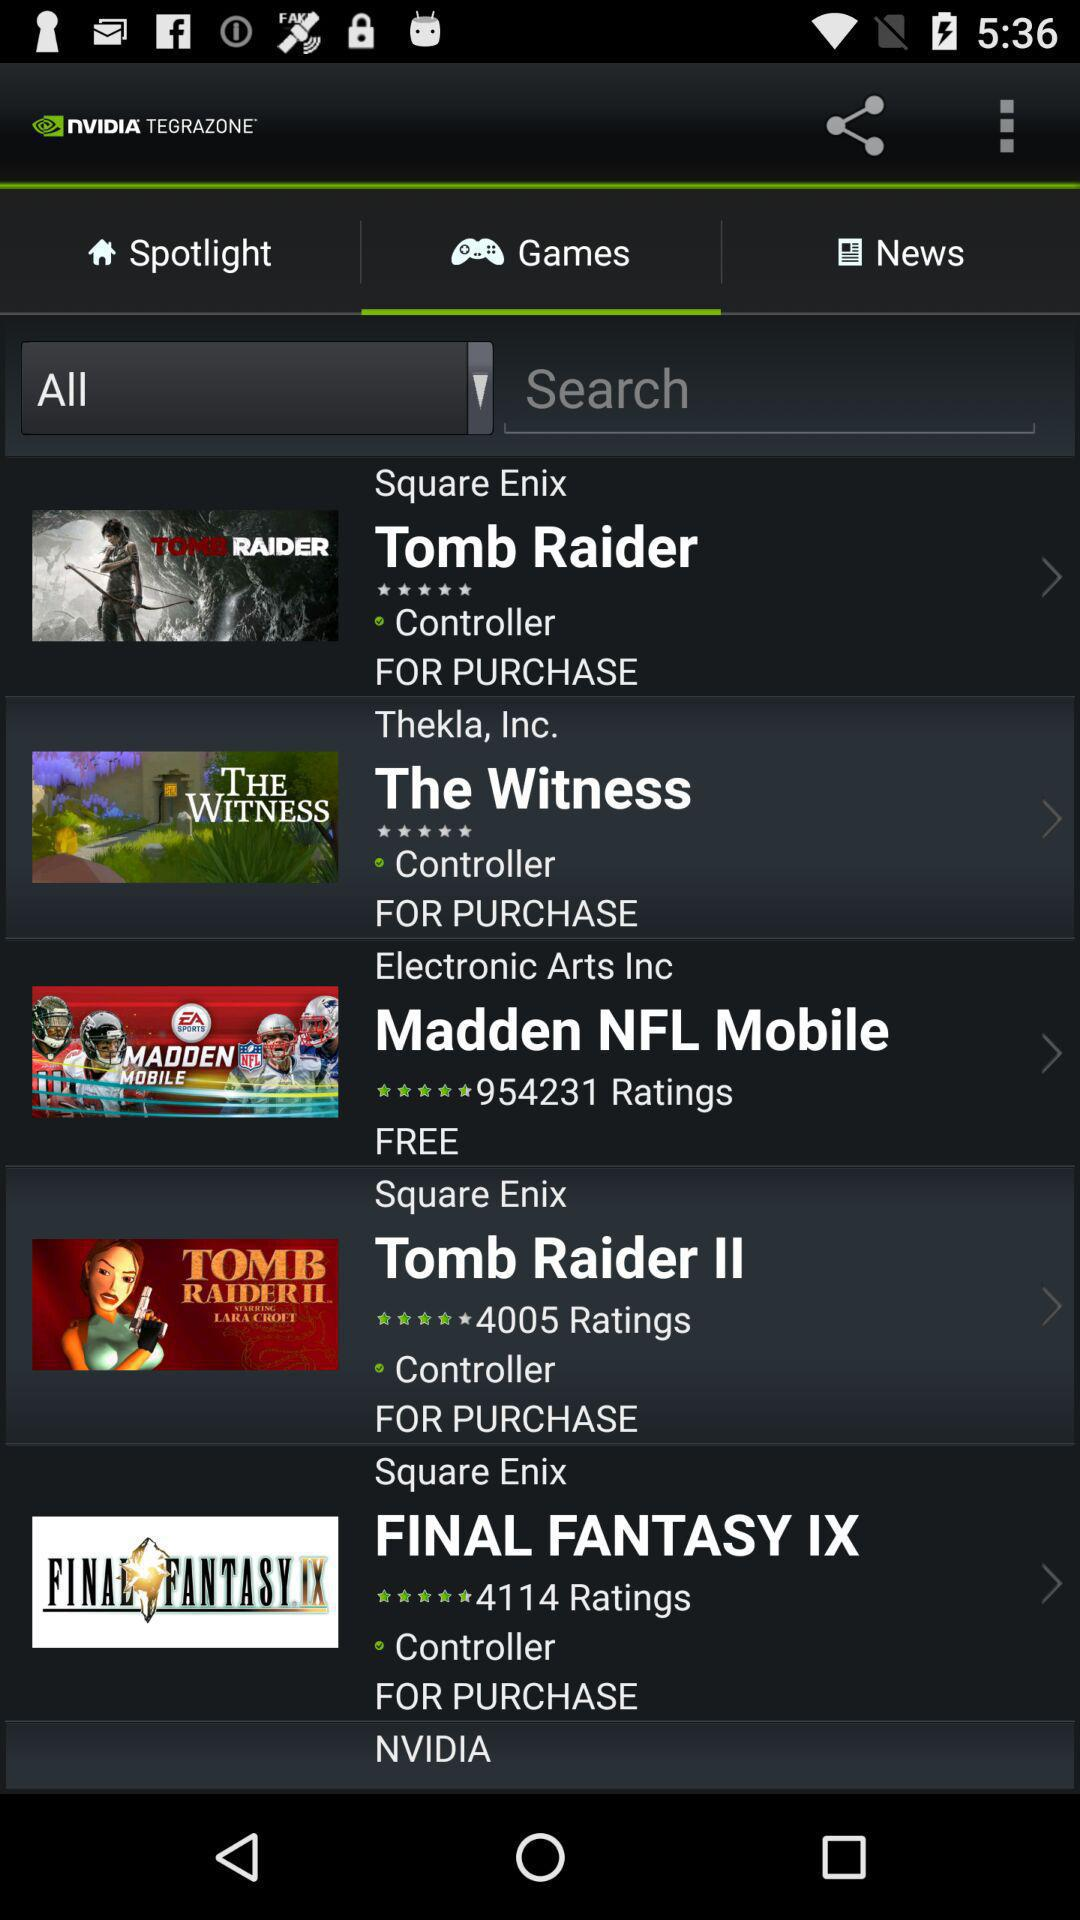What is the name of free game? The name of the free game is "Madden NFL Mobile". 